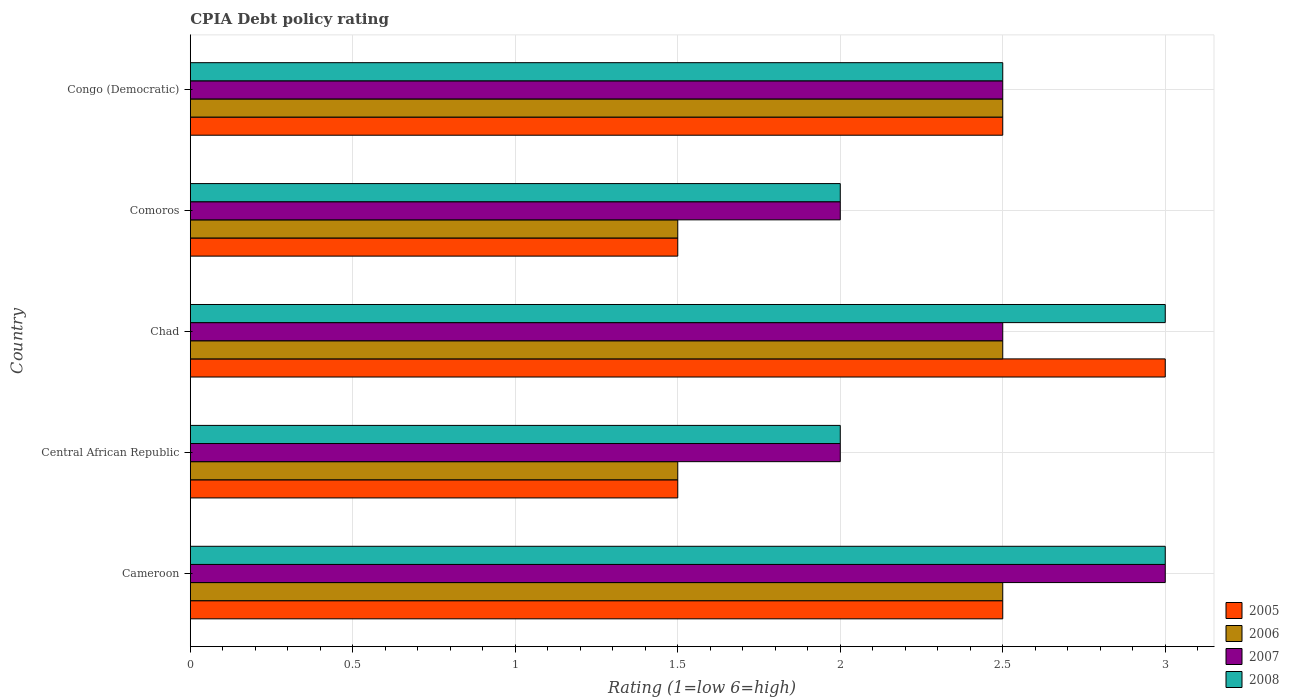How many different coloured bars are there?
Your answer should be compact. 4. How many bars are there on the 4th tick from the top?
Offer a terse response. 4. How many bars are there on the 2nd tick from the bottom?
Provide a succinct answer. 4. What is the label of the 3rd group of bars from the top?
Your response must be concise. Chad. In how many cases, is the number of bars for a given country not equal to the number of legend labels?
Ensure brevity in your answer.  0. Across all countries, what is the minimum CPIA rating in 2006?
Your response must be concise. 1.5. In which country was the CPIA rating in 2008 maximum?
Your answer should be compact. Cameroon. In which country was the CPIA rating in 2008 minimum?
Ensure brevity in your answer.  Central African Republic. What is the total CPIA rating in 2008 in the graph?
Ensure brevity in your answer.  12.5. What is the difference between the CPIA rating in 2006 in Chad and that in Comoros?
Your answer should be very brief. 1. What is the difference between the CPIA rating in 2007 in Chad and the CPIA rating in 2008 in Cameroon?
Your response must be concise. -0.5. What is the average CPIA rating in 2007 per country?
Your response must be concise. 2.4. What is the difference between the CPIA rating in 2005 and CPIA rating in 2006 in Congo (Democratic)?
Your answer should be very brief. 0. In how many countries, is the CPIA rating in 2006 greater than 0.6 ?
Your answer should be compact. 5. Is the CPIA rating in 2007 in Chad less than that in Comoros?
Your answer should be very brief. No. Is the difference between the CPIA rating in 2005 in Central African Republic and Comoros greater than the difference between the CPIA rating in 2006 in Central African Republic and Comoros?
Give a very brief answer. No. What is the difference between the highest and the second highest CPIA rating in 2007?
Your answer should be compact. 0.5. What is the difference between the highest and the lowest CPIA rating in 2008?
Keep it short and to the point. 1. Is it the case that in every country, the sum of the CPIA rating in 2007 and CPIA rating in 2005 is greater than the sum of CPIA rating in 2008 and CPIA rating in 2006?
Make the answer very short. Yes. What does the 1st bar from the top in Comoros represents?
Provide a short and direct response. 2008. What does the 4th bar from the bottom in Central African Republic represents?
Offer a terse response. 2008. How many bars are there?
Offer a terse response. 20. Are all the bars in the graph horizontal?
Keep it short and to the point. Yes. What is the difference between two consecutive major ticks on the X-axis?
Offer a terse response. 0.5. Does the graph contain grids?
Make the answer very short. Yes. Where does the legend appear in the graph?
Offer a terse response. Bottom right. How many legend labels are there?
Your answer should be compact. 4. How are the legend labels stacked?
Make the answer very short. Vertical. What is the title of the graph?
Provide a succinct answer. CPIA Debt policy rating. Does "1970" appear as one of the legend labels in the graph?
Make the answer very short. No. What is the Rating (1=low 6=high) of 2005 in Cameroon?
Keep it short and to the point. 2.5. What is the Rating (1=low 6=high) of 2006 in Central African Republic?
Make the answer very short. 1.5. What is the Rating (1=low 6=high) of 2008 in Chad?
Provide a succinct answer. 3. What is the Rating (1=low 6=high) in 2005 in Comoros?
Offer a very short reply. 1.5. What is the Rating (1=low 6=high) in 2006 in Comoros?
Provide a short and direct response. 1.5. Across all countries, what is the maximum Rating (1=low 6=high) in 2005?
Your response must be concise. 3. Across all countries, what is the maximum Rating (1=low 6=high) of 2006?
Make the answer very short. 2.5. Across all countries, what is the maximum Rating (1=low 6=high) in 2008?
Make the answer very short. 3. What is the total Rating (1=low 6=high) in 2006 in the graph?
Your answer should be compact. 10.5. What is the total Rating (1=low 6=high) of 2007 in the graph?
Keep it short and to the point. 12. What is the total Rating (1=low 6=high) of 2008 in the graph?
Your response must be concise. 12.5. What is the difference between the Rating (1=low 6=high) of 2005 in Cameroon and that in Central African Republic?
Provide a short and direct response. 1. What is the difference between the Rating (1=low 6=high) in 2007 in Cameroon and that in Central African Republic?
Offer a very short reply. 1. What is the difference between the Rating (1=low 6=high) in 2006 in Cameroon and that in Comoros?
Keep it short and to the point. 1. What is the difference between the Rating (1=low 6=high) in 2005 in Cameroon and that in Congo (Democratic)?
Provide a succinct answer. 0. What is the difference between the Rating (1=low 6=high) in 2007 in Cameroon and that in Congo (Democratic)?
Make the answer very short. 0.5. What is the difference between the Rating (1=low 6=high) of 2005 in Central African Republic and that in Chad?
Your answer should be very brief. -1.5. What is the difference between the Rating (1=low 6=high) in 2007 in Central African Republic and that in Chad?
Make the answer very short. -0.5. What is the difference between the Rating (1=low 6=high) of 2008 in Central African Republic and that in Comoros?
Give a very brief answer. 0. What is the difference between the Rating (1=low 6=high) in 2005 in Central African Republic and that in Congo (Democratic)?
Your response must be concise. -1. What is the difference between the Rating (1=low 6=high) in 2007 in Central African Republic and that in Congo (Democratic)?
Provide a short and direct response. -0.5. What is the difference between the Rating (1=low 6=high) of 2008 in Central African Republic and that in Congo (Democratic)?
Give a very brief answer. -0.5. What is the difference between the Rating (1=low 6=high) in 2007 in Chad and that in Comoros?
Give a very brief answer. 0.5. What is the difference between the Rating (1=low 6=high) of 2008 in Chad and that in Comoros?
Your answer should be compact. 1. What is the difference between the Rating (1=low 6=high) of 2005 in Chad and that in Congo (Democratic)?
Your response must be concise. 0.5. What is the difference between the Rating (1=low 6=high) in 2006 in Chad and that in Congo (Democratic)?
Your answer should be compact. 0. What is the difference between the Rating (1=low 6=high) in 2006 in Comoros and that in Congo (Democratic)?
Give a very brief answer. -1. What is the difference between the Rating (1=low 6=high) in 2007 in Comoros and that in Congo (Democratic)?
Provide a succinct answer. -0.5. What is the difference between the Rating (1=low 6=high) of 2005 in Cameroon and the Rating (1=low 6=high) of 2007 in Central African Republic?
Provide a short and direct response. 0.5. What is the difference between the Rating (1=low 6=high) of 2005 in Cameroon and the Rating (1=low 6=high) of 2008 in Central African Republic?
Provide a short and direct response. 0.5. What is the difference between the Rating (1=low 6=high) of 2005 in Cameroon and the Rating (1=low 6=high) of 2006 in Chad?
Offer a very short reply. 0. What is the difference between the Rating (1=low 6=high) of 2005 in Cameroon and the Rating (1=low 6=high) of 2007 in Chad?
Provide a short and direct response. 0. What is the difference between the Rating (1=low 6=high) in 2005 in Cameroon and the Rating (1=low 6=high) in 2008 in Chad?
Provide a short and direct response. -0.5. What is the difference between the Rating (1=low 6=high) of 2006 in Cameroon and the Rating (1=low 6=high) of 2008 in Chad?
Make the answer very short. -0.5. What is the difference between the Rating (1=low 6=high) in 2005 in Cameroon and the Rating (1=low 6=high) in 2006 in Comoros?
Offer a terse response. 1. What is the difference between the Rating (1=low 6=high) in 2005 in Cameroon and the Rating (1=low 6=high) in 2007 in Comoros?
Keep it short and to the point. 0.5. What is the difference between the Rating (1=low 6=high) in 2006 in Cameroon and the Rating (1=low 6=high) in 2008 in Comoros?
Give a very brief answer. 0.5. What is the difference between the Rating (1=low 6=high) of 2005 in Cameroon and the Rating (1=low 6=high) of 2007 in Congo (Democratic)?
Provide a short and direct response. 0. What is the difference between the Rating (1=low 6=high) of 2005 in Cameroon and the Rating (1=low 6=high) of 2008 in Congo (Democratic)?
Offer a terse response. 0. What is the difference between the Rating (1=low 6=high) in 2005 in Central African Republic and the Rating (1=low 6=high) in 2006 in Chad?
Ensure brevity in your answer.  -1. What is the difference between the Rating (1=low 6=high) in 2007 in Central African Republic and the Rating (1=low 6=high) in 2008 in Chad?
Ensure brevity in your answer.  -1. What is the difference between the Rating (1=low 6=high) in 2006 in Central African Republic and the Rating (1=low 6=high) in 2007 in Comoros?
Offer a very short reply. -0.5. What is the difference between the Rating (1=low 6=high) of 2006 in Central African Republic and the Rating (1=low 6=high) of 2008 in Congo (Democratic)?
Offer a terse response. -1. What is the difference between the Rating (1=low 6=high) in 2007 in Central African Republic and the Rating (1=low 6=high) in 2008 in Congo (Democratic)?
Offer a terse response. -0.5. What is the difference between the Rating (1=low 6=high) in 2005 in Chad and the Rating (1=low 6=high) in 2006 in Comoros?
Provide a succinct answer. 1.5. What is the difference between the Rating (1=low 6=high) of 2005 in Chad and the Rating (1=low 6=high) of 2008 in Comoros?
Offer a terse response. 1. What is the difference between the Rating (1=low 6=high) of 2006 in Chad and the Rating (1=low 6=high) of 2008 in Comoros?
Ensure brevity in your answer.  0.5. What is the difference between the Rating (1=low 6=high) of 2007 in Chad and the Rating (1=low 6=high) of 2008 in Comoros?
Your response must be concise. 0.5. What is the difference between the Rating (1=low 6=high) in 2005 in Chad and the Rating (1=low 6=high) in 2006 in Congo (Democratic)?
Ensure brevity in your answer.  0.5. What is the difference between the Rating (1=low 6=high) in 2005 in Chad and the Rating (1=low 6=high) in 2007 in Congo (Democratic)?
Your answer should be very brief. 0.5. What is the difference between the Rating (1=low 6=high) of 2005 in Chad and the Rating (1=low 6=high) of 2008 in Congo (Democratic)?
Give a very brief answer. 0.5. What is the difference between the Rating (1=low 6=high) in 2006 in Chad and the Rating (1=low 6=high) in 2007 in Congo (Democratic)?
Offer a very short reply. 0. What is the difference between the Rating (1=low 6=high) in 2006 in Chad and the Rating (1=low 6=high) in 2008 in Congo (Democratic)?
Offer a terse response. 0. What is the difference between the Rating (1=low 6=high) in 2007 in Chad and the Rating (1=low 6=high) in 2008 in Congo (Democratic)?
Your response must be concise. 0. What is the difference between the Rating (1=low 6=high) of 2005 in Comoros and the Rating (1=low 6=high) of 2006 in Congo (Democratic)?
Keep it short and to the point. -1. What is the difference between the Rating (1=low 6=high) in 2006 in Comoros and the Rating (1=low 6=high) in 2007 in Congo (Democratic)?
Provide a short and direct response. -1. What is the difference between the Rating (1=low 6=high) of 2006 in Comoros and the Rating (1=low 6=high) of 2008 in Congo (Democratic)?
Make the answer very short. -1. What is the difference between the Rating (1=low 6=high) of 2007 in Comoros and the Rating (1=low 6=high) of 2008 in Congo (Democratic)?
Provide a short and direct response. -0.5. What is the average Rating (1=low 6=high) of 2005 per country?
Offer a very short reply. 2.2. What is the average Rating (1=low 6=high) of 2007 per country?
Provide a short and direct response. 2.4. What is the average Rating (1=low 6=high) in 2008 per country?
Make the answer very short. 2.5. What is the difference between the Rating (1=low 6=high) of 2005 and Rating (1=low 6=high) of 2006 in Cameroon?
Your answer should be very brief. 0. What is the difference between the Rating (1=low 6=high) of 2005 and Rating (1=low 6=high) of 2008 in Cameroon?
Provide a short and direct response. -0.5. What is the difference between the Rating (1=low 6=high) of 2005 and Rating (1=low 6=high) of 2006 in Central African Republic?
Your answer should be very brief. 0. What is the difference between the Rating (1=low 6=high) of 2006 and Rating (1=low 6=high) of 2007 in Central African Republic?
Provide a short and direct response. -0.5. What is the difference between the Rating (1=low 6=high) in 2005 and Rating (1=low 6=high) in 2006 in Chad?
Provide a short and direct response. 0.5. What is the difference between the Rating (1=low 6=high) in 2005 and Rating (1=low 6=high) in 2007 in Chad?
Keep it short and to the point. 0.5. What is the difference between the Rating (1=low 6=high) of 2005 and Rating (1=low 6=high) of 2008 in Chad?
Your answer should be compact. 0. What is the difference between the Rating (1=low 6=high) in 2006 and Rating (1=low 6=high) in 2007 in Chad?
Keep it short and to the point. 0. What is the difference between the Rating (1=low 6=high) of 2005 and Rating (1=low 6=high) of 2006 in Comoros?
Your answer should be very brief. 0. What is the difference between the Rating (1=low 6=high) in 2005 and Rating (1=low 6=high) in 2008 in Comoros?
Provide a succinct answer. -0.5. What is the difference between the Rating (1=low 6=high) in 2006 and Rating (1=low 6=high) in 2007 in Comoros?
Keep it short and to the point. -0.5. What is the difference between the Rating (1=low 6=high) in 2006 and Rating (1=low 6=high) in 2008 in Comoros?
Make the answer very short. -0.5. What is the difference between the Rating (1=low 6=high) in 2005 and Rating (1=low 6=high) in 2006 in Congo (Democratic)?
Make the answer very short. 0. What is the difference between the Rating (1=low 6=high) in 2006 and Rating (1=low 6=high) in 2007 in Congo (Democratic)?
Keep it short and to the point. 0. What is the difference between the Rating (1=low 6=high) in 2007 and Rating (1=low 6=high) in 2008 in Congo (Democratic)?
Your answer should be very brief. 0. What is the ratio of the Rating (1=low 6=high) of 2006 in Cameroon to that in Central African Republic?
Give a very brief answer. 1.67. What is the ratio of the Rating (1=low 6=high) of 2007 in Cameroon to that in Central African Republic?
Your answer should be compact. 1.5. What is the ratio of the Rating (1=low 6=high) of 2008 in Cameroon to that in Chad?
Keep it short and to the point. 1. What is the ratio of the Rating (1=low 6=high) of 2005 in Cameroon to that in Congo (Democratic)?
Your answer should be compact. 1. What is the ratio of the Rating (1=low 6=high) of 2006 in Cameroon to that in Congo (Democratic)?
Provide a succinct answer. 1. What is the ratio of the Rating (1=low 6=high) in 2007 in Cameroon to that in Congo (Democratic)?
Ensure brevity in your answer.  1.2. What is the ratio of the Rating (1=low 6=high) of 2008 in Cameroon to that in Congo (Democratic)?
Offer a very short reply. 1.2. What is the ratio of the Rating (1=low 6=high) in 2006 in Central African Republic to that in Chad?
Provide a succinct answer. 0.6. What is the ratio of the Rating (1=low 6=high) of 2007 in Central African Republic to that in Chad?
Your response must be concise. 0.8. What is the ratio of the Rating (1=low 6=high) of 2008 in Central African Republic to that in Chad?
Offer a terse response. 0.67. What is the ratio of the Rating (1=low 6=high) of 2006 in Central African Republic to that in Comoros?
Provide a short and direct response. 1. What is the ratio of the Rating (1=low 6=high) of 2008 in Central African Republic to that in Comoros?
Your answer should be compact. 1. What is the ratio of the Rating (1=low 6=high) in 2007 in Central African Republic to that in Congo (Democratic)?
Make the answer very short. 0.8. What is the ratio of the Rating (1=low 6=high) in 2008 in Central African Republic to that in Congo (Democratic)?
Give a very brief answer. 0.8. What is the ratio of the Rating (1=low 6=high) in 2006 in Chad to that in Comoros?
Offer a terse response. 1.67. What is the ratio of the Rating (1=low 6=high) in 2007 in Chad to that in Comoros?
Provide a short and direct response. 1.25. What is the ratio of the Rating (1=low 6=high) of 2006 in Chad to that in Congo (Democratic)?
Provide a short and direct response. 1. What is the ratio of the Rating (1=low 6=high) in 2007 in Chad to that in Congo (Democratic)?
Ensure brevity in your answer.  1. What is the ratio of the Rating (1=low 6=high) in 2005 in Comoros to that in Congo (Democratic)?
Provide a short and direct response. 0.6. What is the difference between the highest and the second highest Rating (1=low 6=high) of 2006?
Make the answer very short. 0. What is the difference between the highest and the second highest Rating (1=low 6=high) of 2008?
Provide a short and direct response. 0. What is the difference between the highest and the lowest Rating (1=low 6=high) in 2006?
Keep it short and to the point. 1. What is the difference between the highest and the lowest Rating (1=low 6=high) of 2008?
Your answer should be very brief. 1. 